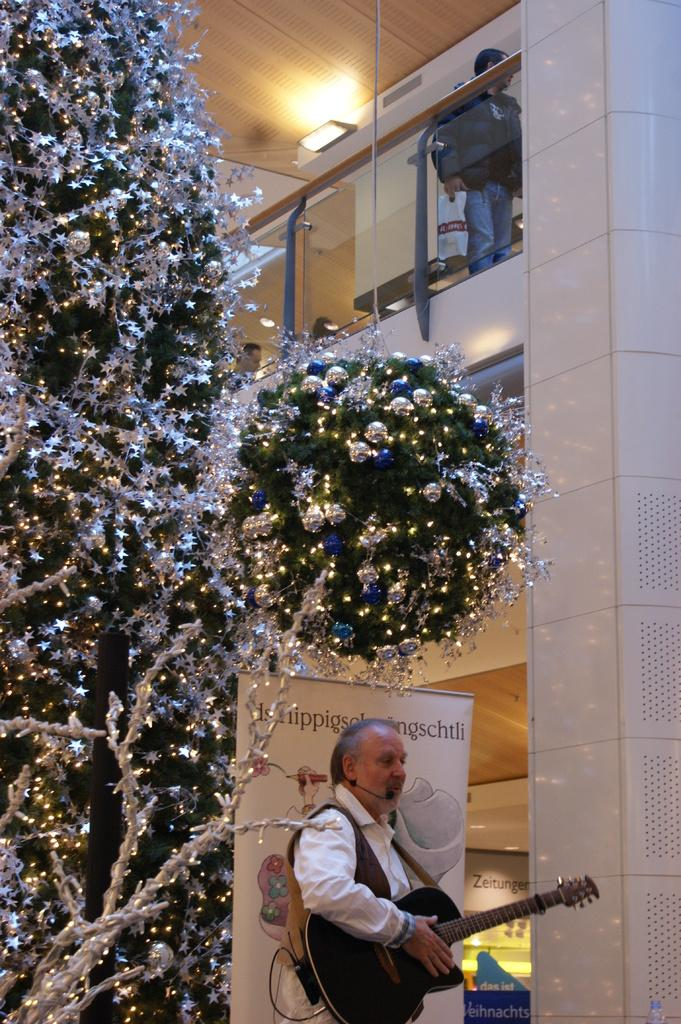What type of structure can be seen in the image? There is a wall in the image. What seasonal decoration is present in the image? There is a Christmas tree in the image. What is the person on the left side of the image holding? The person is holding a guitar in the image. What additional signage or message is present in the image? There is a banner in the image. What is the person on the right side of the image holding? There is a person holding a cover in the image. What type of coal is being mined by the spy in the image? There is no coal or spy present in the image. How does the land in the image contribute to the overall scene? There is no reference to land in the image, as it primarily features a wall, a Christmas tree, and people holding a guitar and a cover. 